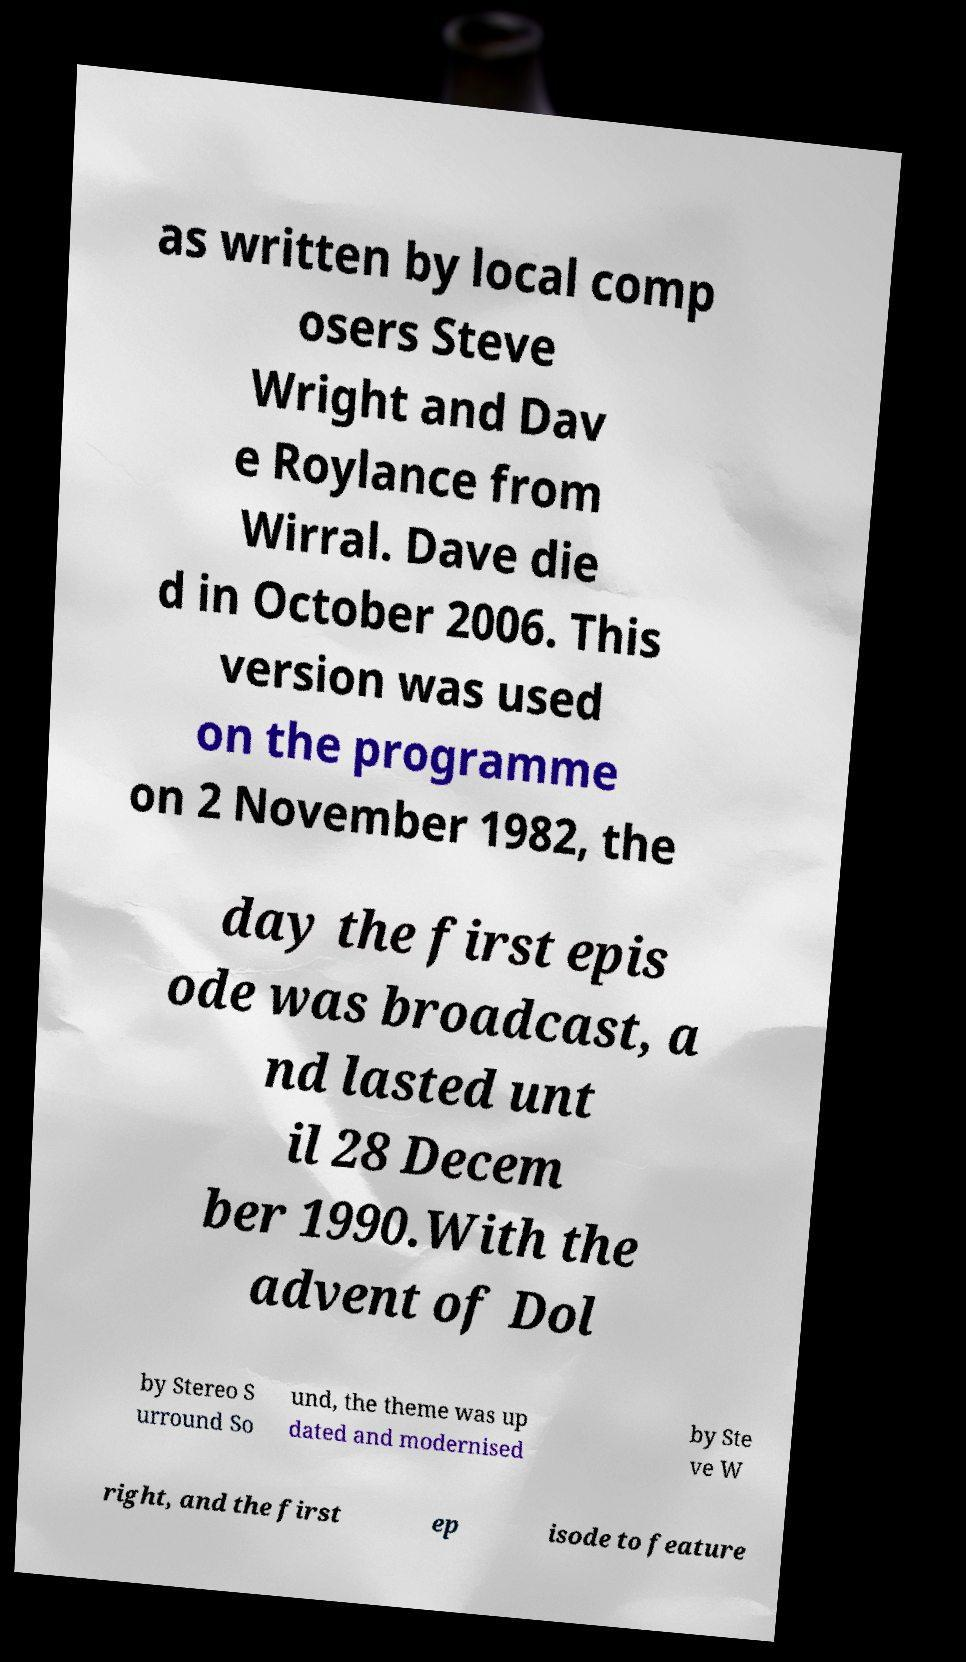For documentation purposes, I need the text within this image transcribed. Could you provide that? as written by local comp osers Steve Wright and Dav e Roylance from Wirral. Dave die d in October 2006. This version was used on the programme on 2 November 1982, the day the first epis ode was broadcast, a nd lasted unt il 28 Decem ber 1990.With the advent of Dol by Stereo S urround So und, the theme was up dated and modernised by Ste ve W right, and the first ep isode to feature 